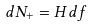<formula> <loc_0><loc_0><loc_500><loc_500>d N _ { + } = H d f</formula> 